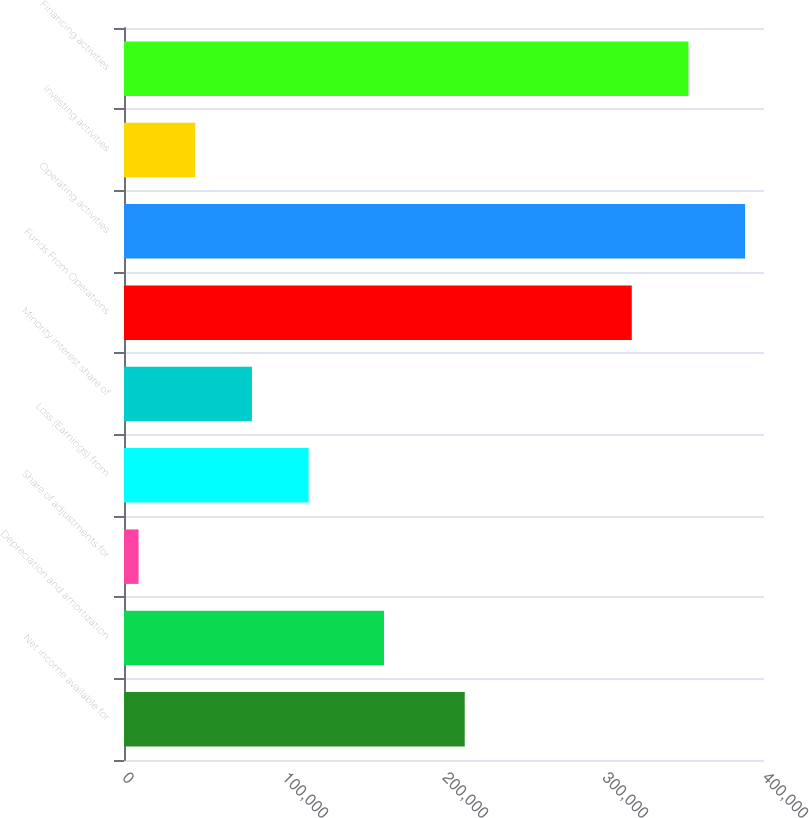Convert chart. <chart><loc_0><loc_0><loc_500><loc_500><bar_chart><fcel>Net income available for<fcel>Depreciation and amortization<fcel>Share of adjustments for<fcel>Loss (Earnings) from<fcel>Minority interest share of<fcel>Funds From Operations<fcel>Operating activities<fcel>Investing activities<fcel>Financing activities<nl><fcel>212958<fcel>162523<fcel>9104<fcel>115378<fcel>79953.2<fcel>317360<fcel>388209<fcel>44528.6<fcel>352785<nl></chart> 